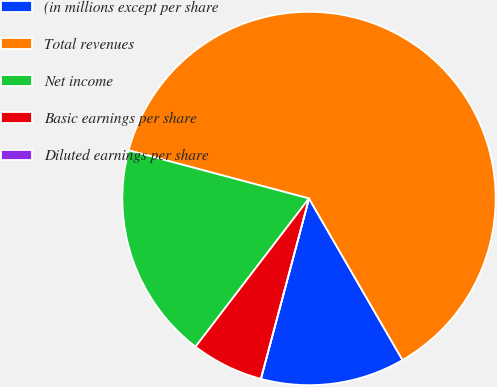<chart> <loc_0><loc_0><loc_500><loc_500><pie_chart><fcel>(in millions except per share<fcel>Total revenues<fcel>Net income<fcel>Basic earnings per share<fcel>Diluted earnings per share<nl><fcel>12.5%<fcel>62.49%<fcel>18.75%<fcel>6.25%<fcel>0.0%<nl></chart> 